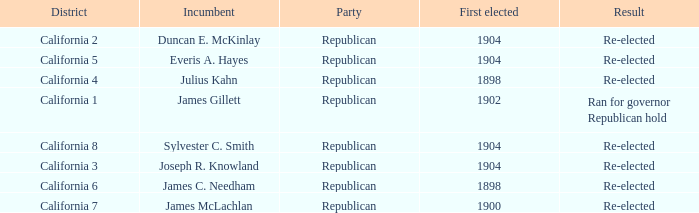Which Incumbent has a District of California 8? Sylvester C. Smith. 